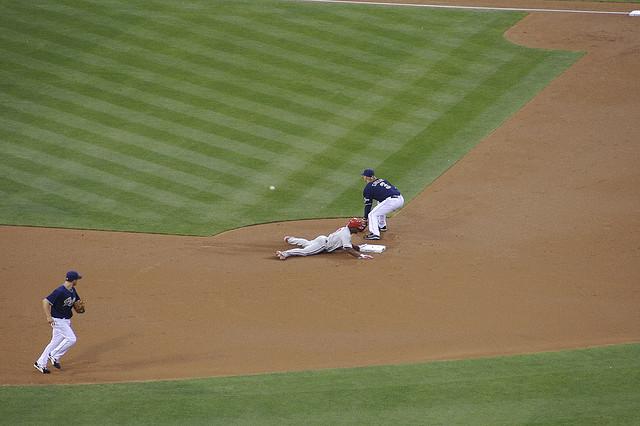What sport are the men playing?
Keep it brief. Baseball. What color is the runner's shirt?
Give a very brief answer. White. How many players are on the field?
Keep it brief. 3. What number is on the baseman's Jersey?
Quick response, please. 3. Where will the battery go if he gets a hit?
Short answer required. First base. What position does the man in the middle play?
Keep it brief. Batter. Why is the man on the ground?
Concise answer only. He is sliding. What direction was the grass mowed?
Be succinct. Checked. What number is the man falling?
Be succinct. 3. 